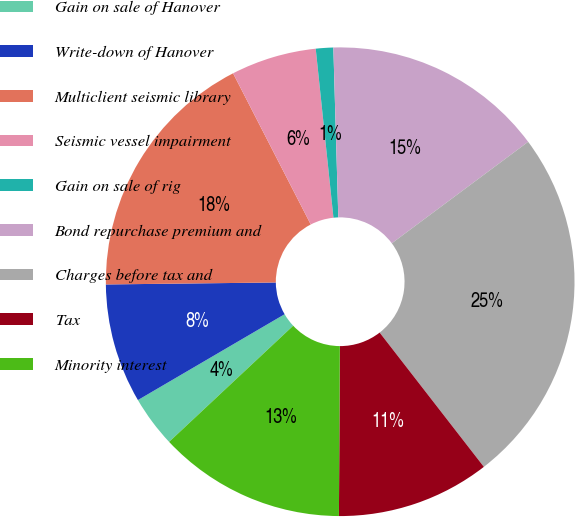<chart> <loc_0><loc_0><loc_500><loc_500><pie_chart><fcel>Gain on sale of Hanover<fcel>Write-down of Hanover<fcel>Multiclient seismic library<fcel>Seismic vessel impairment<fcel>Gain on sale of rig<fcel>Bond repurchase premium and<fcel>Charges before tax and<fcel>Tax<fcel>Minority interest<nl><fcel>3.55%<fcel>8.24%<fcel>17.63%<fcel>5.89%<fcel>1.2%<fcel>15.28%<fcel>24.68%<fcel>10.59%<fcel>12.94%<nl></chart> 